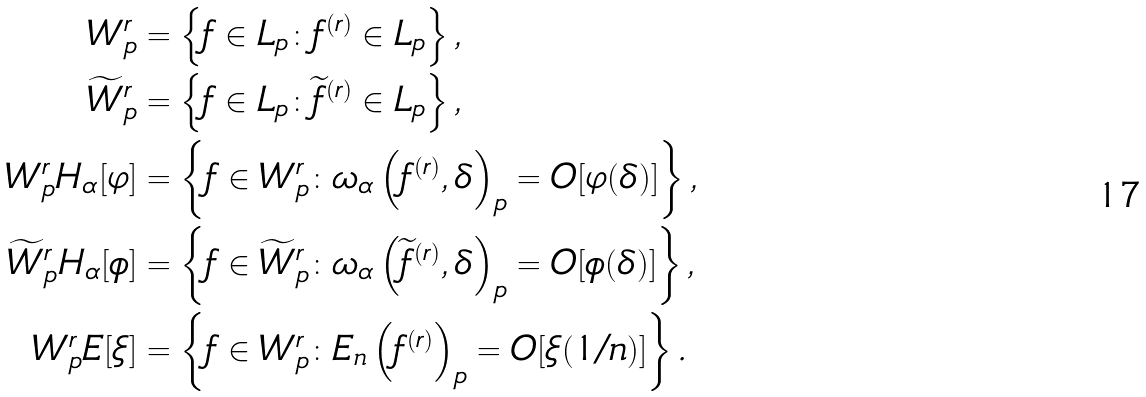Convert formula to latex. <formula><loc_0><loc_0><loc_500><loc_500>W ^ { r } _ { p } & = \left \{ f \in L _ { p } \colon f ^ { ( r ) } \in L _ { p } \right \} , \\ \widetilde { W } ^ { r } _ { p } & = \left \{ f \in L _ { p } \colon \widetilde { f } ^ { ( r ) } \in L _ { p } \right \} , \\ { W } ^ { r } _ { p } H _ { \alpha } [ \varphi ] & = \left \{ f \in W ^ { r } _ { p } \colon \omega _ { \alpha } \left ( f ^ { ( r ) } , \delta \right ) _ { p } = O [ \varphi ( \delta ) ] \right \} , \\ \widetilde { W } ^ { r } _ { p } H _ { \alpha } [ \phi ] & = \left \{ f \in \widetilde { W } ^ { r } _ { p } \colon \omega _ { \alpha } \left ( \widetilde { f } ^ { ( r ) } , \delta \right ) _ { p } = O [ \phi ( \delta ) ] \right \} , \\ { W } ^ { r } _ { p } E [ \xi ] & = \left \{ f \in W ^ { r } _ { p } \colon E _ { n } \left ( f ^ { ( r ) } \right ) _ { p } = O [ \xi ( 1 / n ) ] \right \} .</formula> 